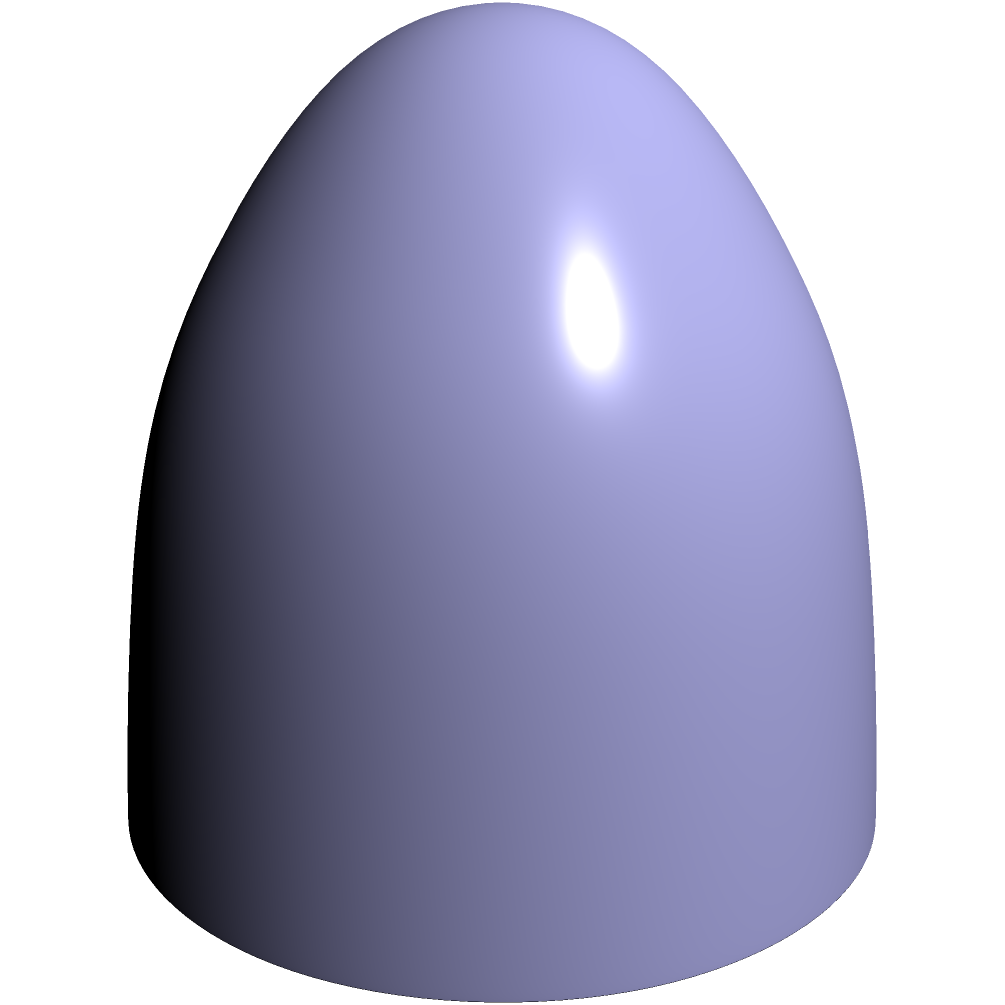In the context of global trade routes, consider a sphere representing Earth. Two major trade hubs, A and B, are located on the surface as shown. What type of curve represents the shortest path between these points, and how does this relate to efficient international shipping routes? To understand the shortest path between two points on a sphere, we need to consider the principles of Non-Euclidean Geometry. Here's a step-by-step explanation:

1. On a flat surface (Euclidean geometry), the shortest path between two points is a straight line. However, on a curved surface like a sphere, this is not the case.

2. The shortest path between two points on a sphere is called a geodesic. On a sphere, geodesics are great circles.

3. A great circle is the intersection of a sphere with a plane that passes through the center of the sphere. It represents the largest possible circle that can be drawn on the sphere's surface.

4. The arc of a great circle passing through points A and B is shown in red on the diagram. This arc represents the shortest path between A and B on the surface of the sphere.

5. In the context of global trade:
   a) The sphere represents Earth.
   b) Points A and B represent major trade hubs.
   c) The red arc represents the most efficient shipping route between these hubs.

6. This concept is crucial for international shipping and air travel routes. Ships and aircraft often follow great circle routes to minimize travel distance and fuel consumption.

7. The distance along this geodesic can be calculated using the formula:

   $$d = R \cdot \arccos(\sin\phi_1 \sin\phi_2 + \cos\phi_1 \cos\phi_2 \cos(\lambda_2 - \lambda_1))$$

   Where $R$ is the Earth's radius, $\phi_1$, $\phi_2$ are latitudes, and $\lambda_1$, $\lambda_2$ are longitudes of the two points.

8. Understanding and utilizing these geodesic paths is essential for optimizing global trade routes, reducing transportation costs, and promoting efficient international commerce.
Answer: Great circle arc (geodesic) 